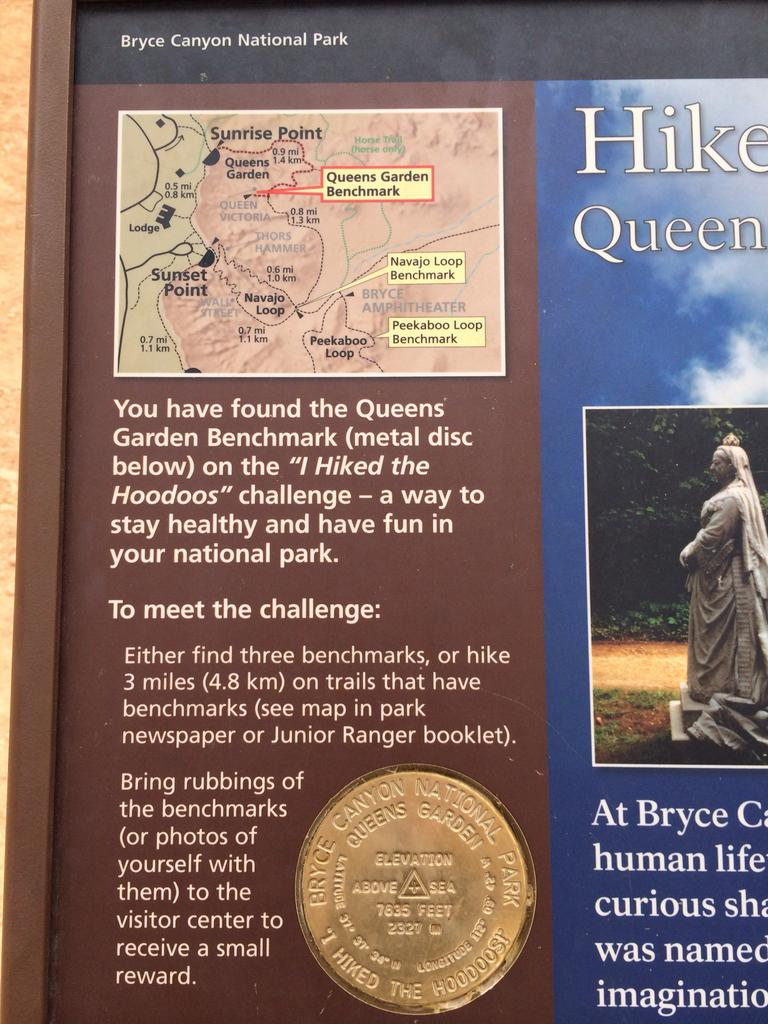Provide a one-sentence caption for the provided image. A sign with a map of Bryce Canyon National Park in the corner. 